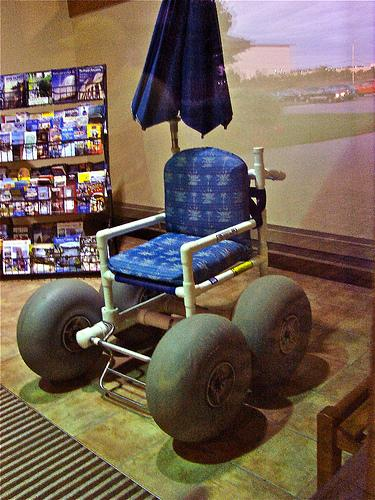What is attached to the chair?

Choices:
A) knives
B) apples
C) wheels
D) balloons wheels 